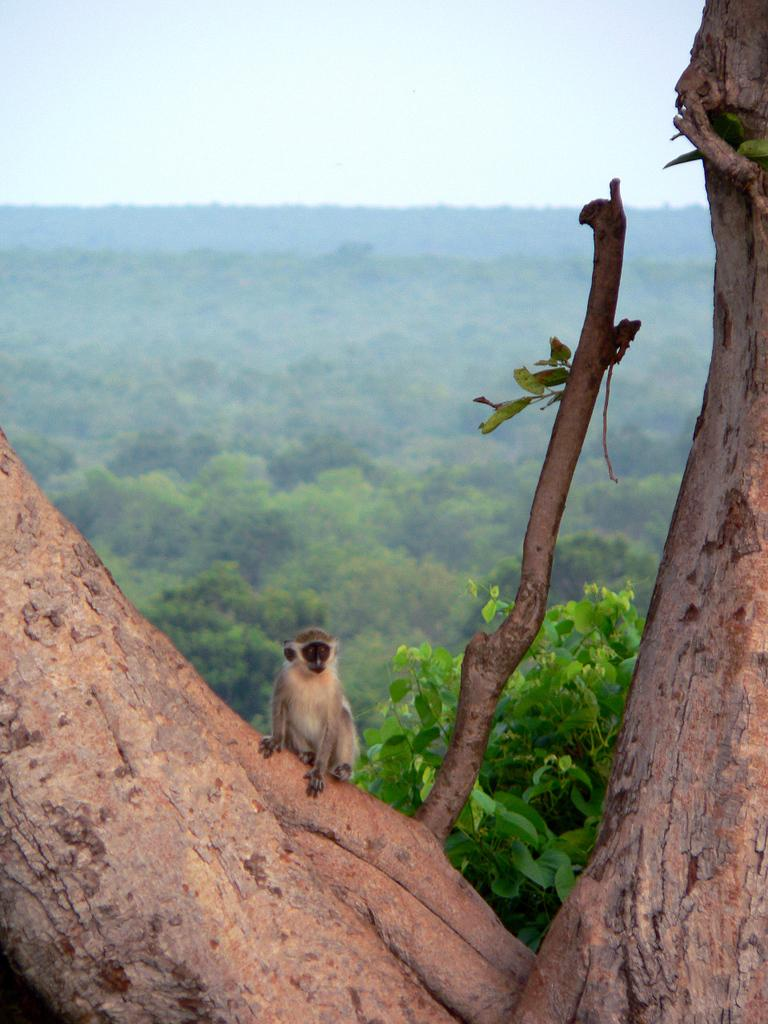What animal is present in the image? There is a monkey in the image. Where is the monkey located? The monkey is on a tree. What can be seen in the background of the image? There are trees in the background of the image. What is visible at the top of the image? The sky is visible at the top of the image. What is the monkey's income in the image? Monkeys do not have income, so this question cannot be answered. 